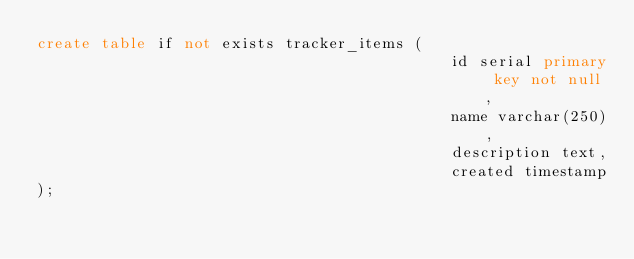Convert code to text. <code><loc_0><loc_0><loc_500><loc_500><_SQL_>create table if not exists tracker_items (
                                             id serial primary key not null,
                                             name varchar(250),
                                             description text,
                                             created timestamp
);</code> 